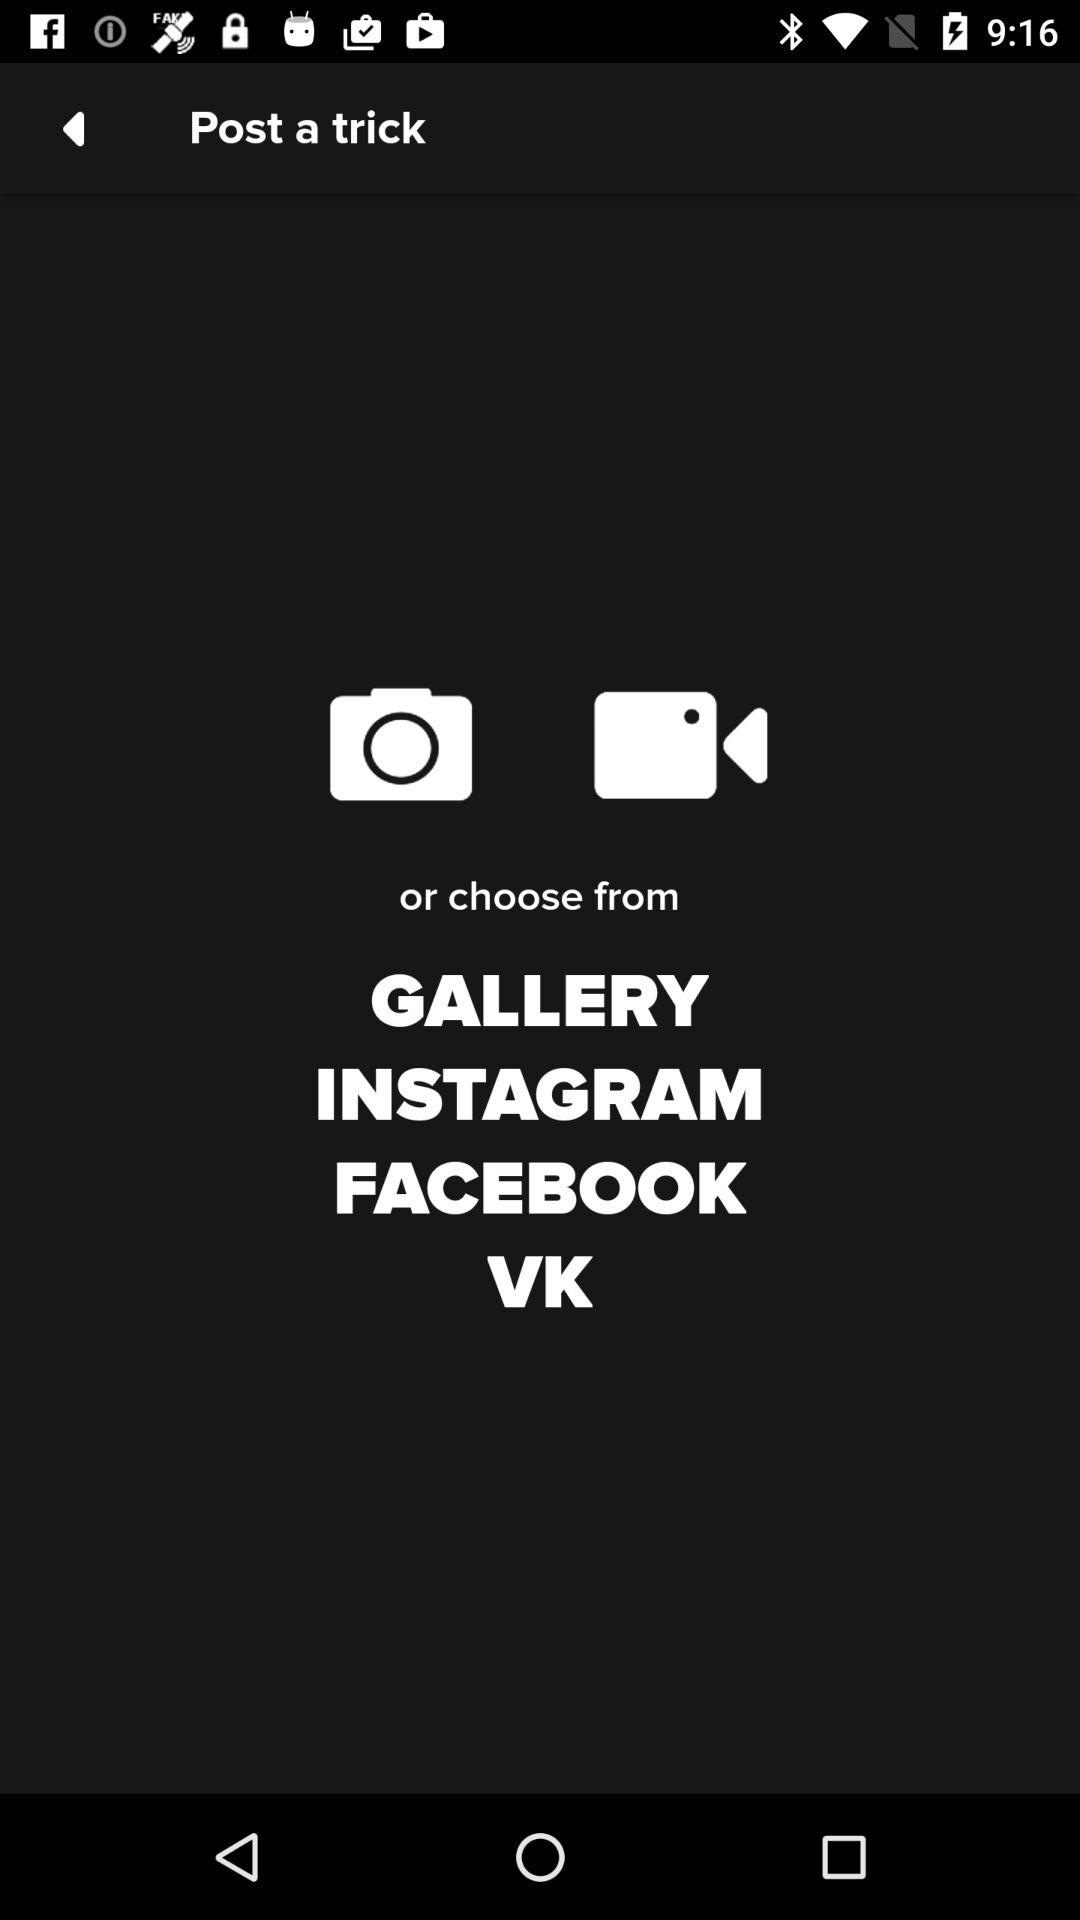What options are there to select a photo to post? The options are "Camera", "Video", "GALLERY", "INSTAGRAM", "FACEBOOK" and "VK". 